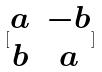<formula> <loc_0><loc_0><loc_500><loc_500>[ \begin{matrix} a & - b \\ b & a \end{matrix} ]</formula> 